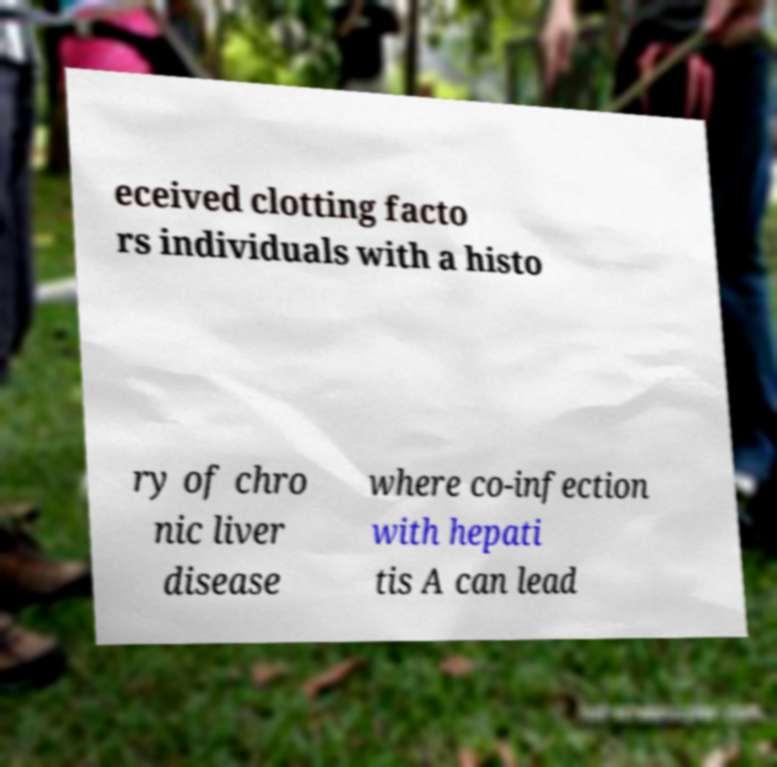Can you accurately transcribe the text from the provided image for me? eceived clotting facto rs individuals with a histo ry of chro nic liver disease where co-infection with hepati tis A can lead 